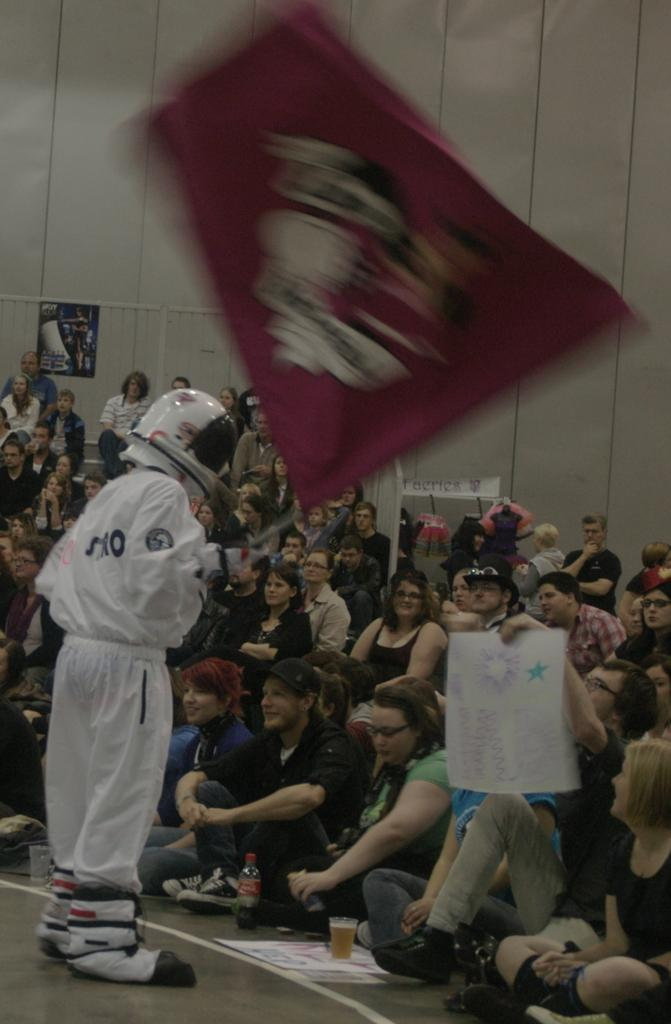How many people are in the image? There is a group of people in the image, but the exact number is not specified. What are the people in the image doing? Some people are sitting, while others are standing. What objects can be seen in the image related to drinks? There is a bottle and a glass in the image. What decorative elements are present in the image? Banners are present in the image. What can be seen in the background of the image? There is a wall in the background of the image. What type of loss is being experienced by the beetle in the image? There is no beetle present in the image, so it is not possible to determine if any loss is being experienced. 